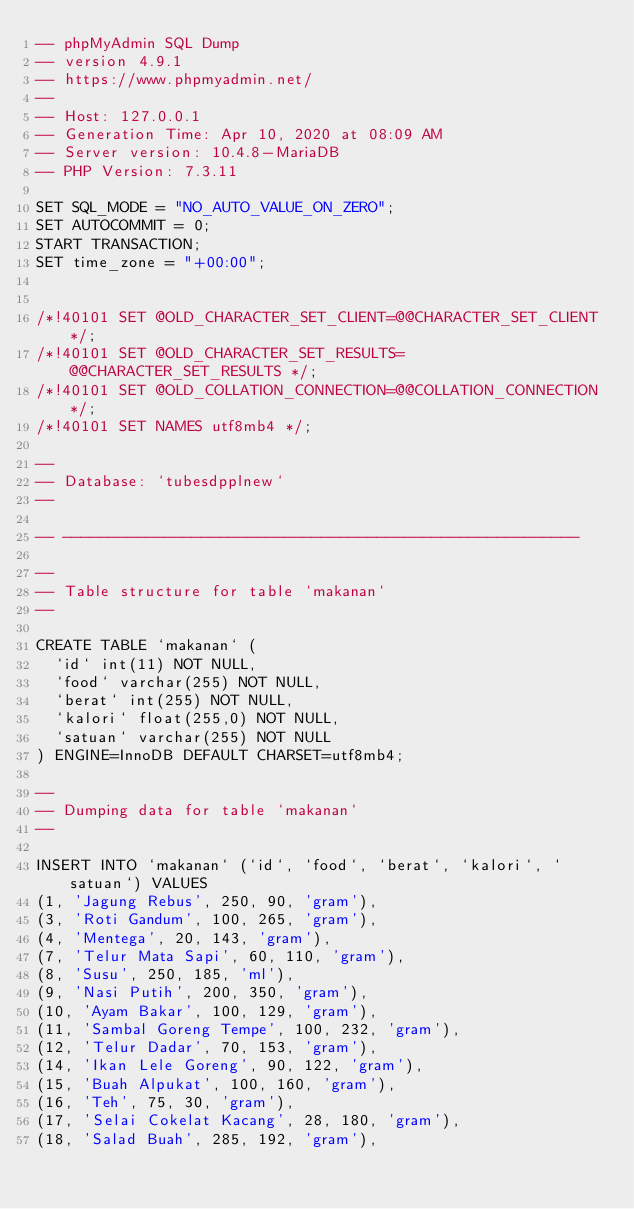<code> <loc_0><loc_0><loc_500><loc_500><_SQL_>-- phpMyAdmin SQL Dump
-- version 4.9.1
-- https://www.phpmyadmin.net/
--
-- Host: 127.0.0.1
-- Generation Time: Apr 10, 2020 at 08:09 AM
-- Server version: 10.4.8-MariaDB
-- PHP Version: 7.3.11

SET SQL_MODE = "NO_AUTO_VALUE_ON_ZERO";
SET AUTOCOMMIT = 0;
START TRANSACTION;
SET time_zone = "+00:00";


/*!40101 SET @OLD_CHARACTER_SET_CLIENT=@@CHARACTER_SET_CLIENT */;
/*!40101 SET @OLD_CHARACTER_SET_RESULTS=@@CHARACTER_SET_RESULTS */;
/*!40101 SET @OLD_COLLATION_CONNECTION=@@COLLATION_CONNECTION */;
/*!40101 SET NAMES utf8mb4 */;

--
-- Database: `tubesdpplnew`
--

-- --------------------------------------------------------

--
-- Table structure for table `makanan`
--

CREATE TABLE `makanan` (
  `id` int(11) NOT NULL,
  `food` varchar(255) NOT NULL,
  `berat` int(255) NOT NULL,
  `kalori` float(255,0) NOT NULL,
  `satuan` varchar(255) NOT NULL
) ENGINE=InnoDB DEFAULT CHARSET=utf8mb4;

--
-- Dumping data for table `makanan`
--

INSERT INTO `makanan` (`id`, `food`, `berat`, `kalori`, `satuan`) VALUES
(1, 'Jagung Rebus', 250, 90, 'gram'),
(3, 'Roti Gandum', 100, 265, 'gram'),
(4, 'Mentega', 20, 143, 'gram'),
(7, 'Telur Mata Sapi', 60, 110, 'gram'),
(8, 'Susu', 250, 185, 'ml'),
(9, 'Nasi Putih', 200, 350, 'gram'),
(10, 'Ayam Bakar', 100, 129, 'gram'),
(11, 'Sambal Goreng Tempe', 100, 232, 'gram'),
(12, 'Telur Dadar', 70, 153, 'gram'),
(14, 'Ikan Lele Goreng', 90, 122, 'gram'),
(15, 'Buah Alpukat', 100, 160, 'gram'),
(16, 'Teh', 75, 30, 'gram'),
(17, 'Selai Cokelat Kacang', 28, 180, 'gram'),
(18, 'Salad Buah', 285, 192, 'gram'),</code> 